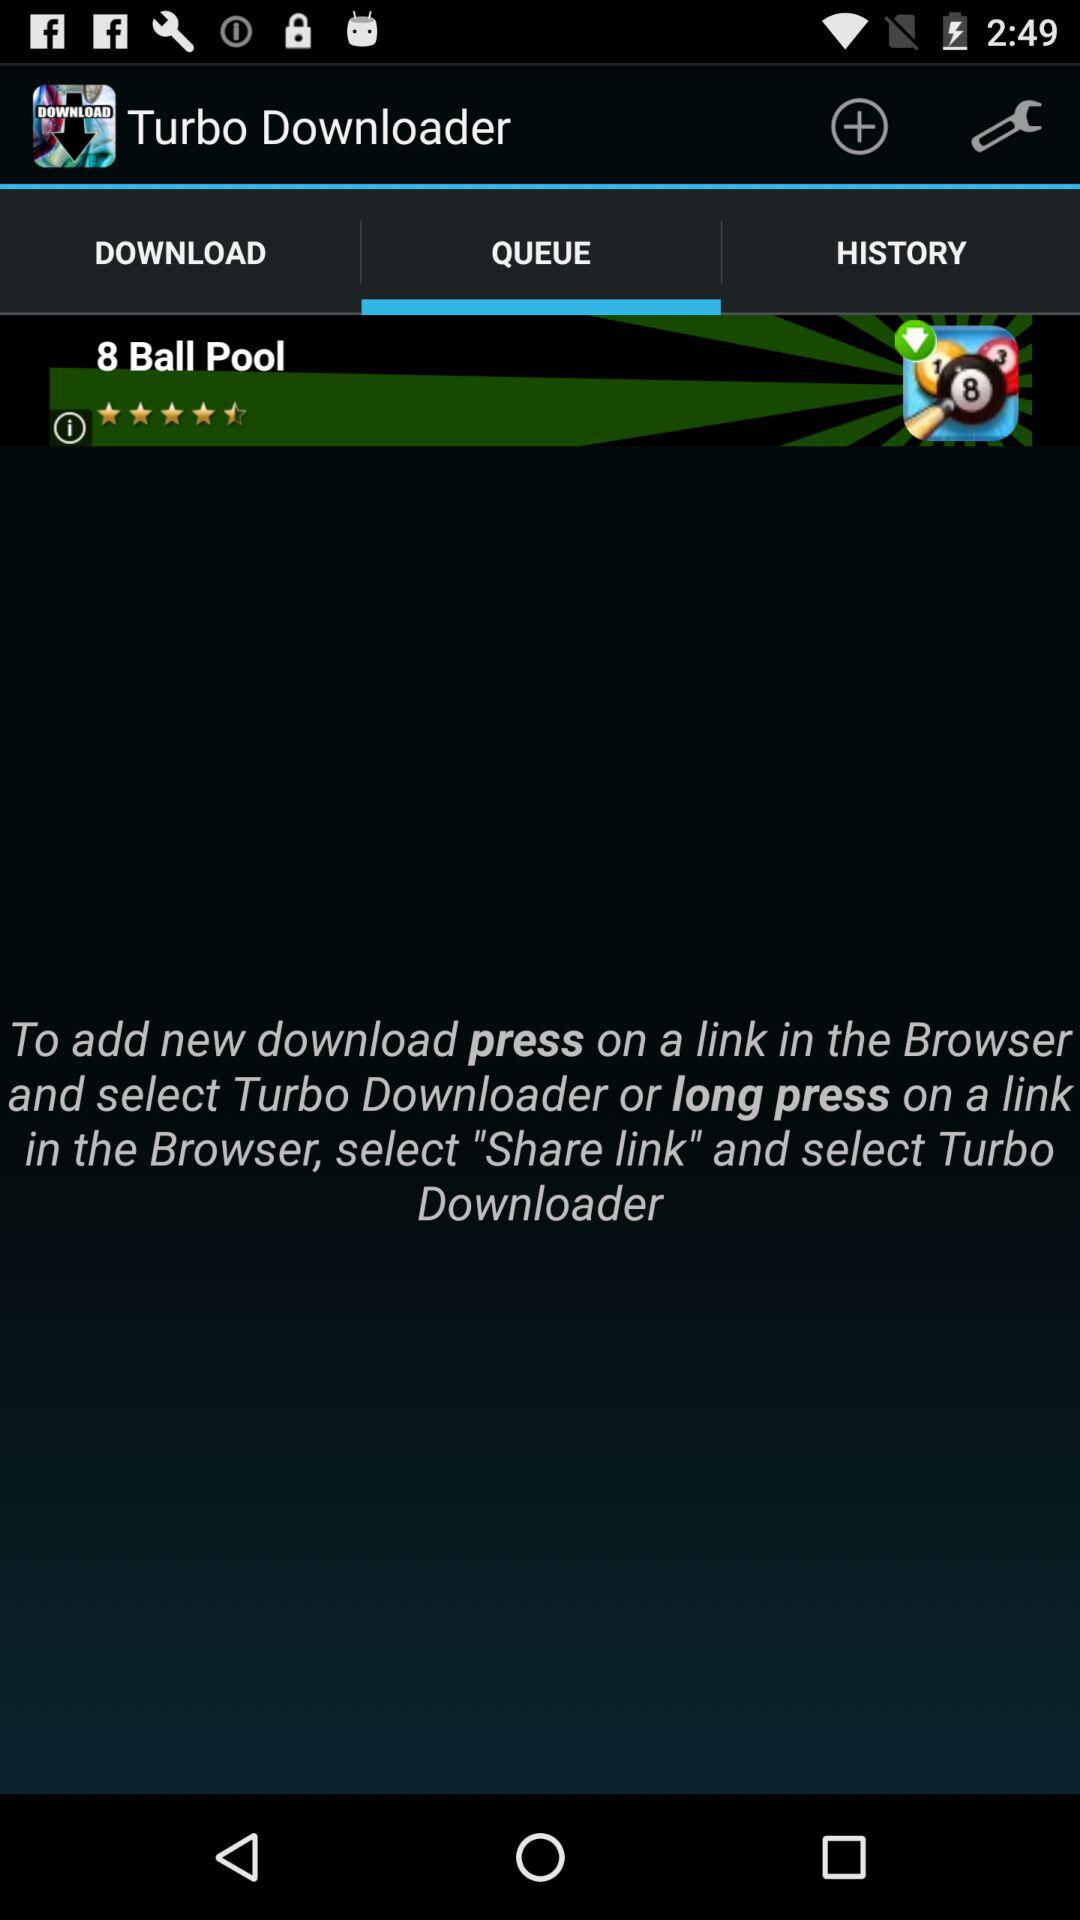Which tab is selected? The selected tab is "QUEUE". 